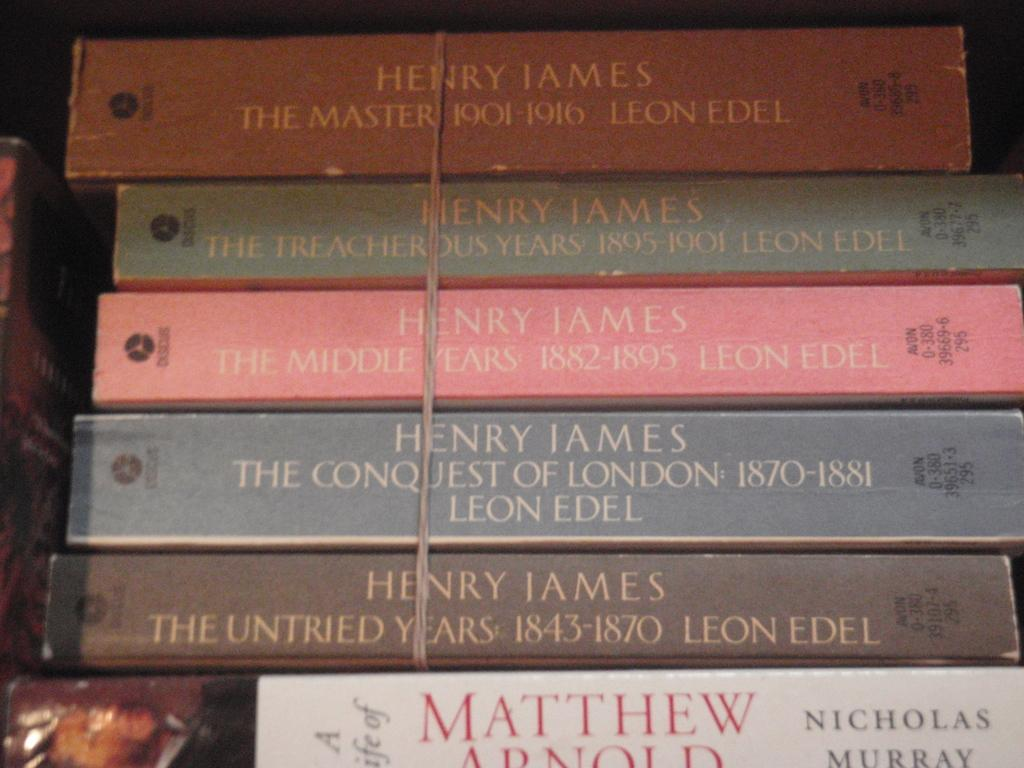<image>
Offer a succinct explanation of the picture presented. Four books by Henry James and one by Nicholas Murray. 